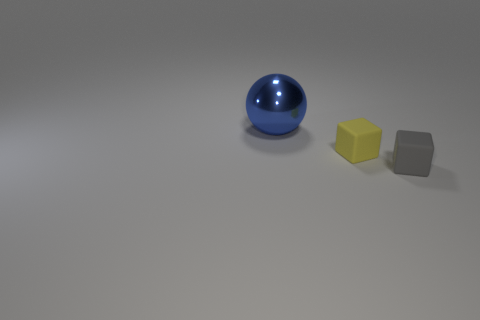Is there anything else that is the same size as the blue metal object?
Your answer should be very brief. No. Do the matte thing that is right of the small yellow rubber block and the matte object that is left of the gray matte cube have the same shape?
Make the answer very short. Yes. There is a yellow rubber thing; does it have the same size as the metal sphere on the left side of the gray rubber object?
Keep it short and to the point. No. Is the number of yellow rubber objects greater than the number of brown cylinders?
Make the answer very short. Yes. Is the material of the cube in front of the yellow rubber cube the same as the object that is behind the small yellow cube?
Give a very brief answer. No. What is the big ball made of?
Your answer should be very brief. Metal. Are there more small objects that are in front of the big blue shiny object than tiny purple shiny cylinders?
Keep it short and to the point. Yes. How many large blue balls are to the right of the blue ball that is to the left of the block to the right of the tiny yellow matte cube?
Your answer should be compact. 0. The ball is what color?
Give a very brief answer. Blue. Is the number of blue shiny objects that are on the left side of the yellow matte cube greater than the number of gray matte blocks that are to the left of the blue shiny object?
Offer a very short reply. Yes. 